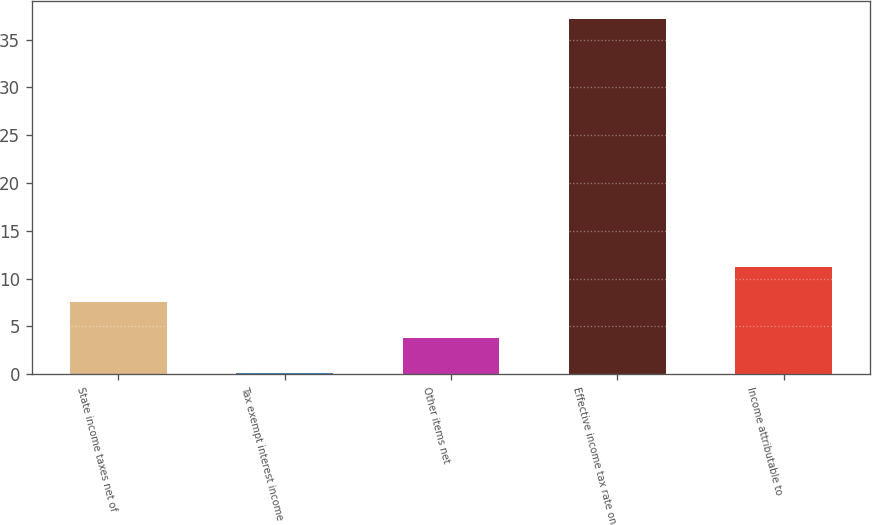<chart> <loc_0><loc_0><loc_500><loc_500><bar_chart><fcel>State income taxes net of<fcel>Tax exempt interest income<fcel>Other items net<fcel>Effective income tax rate on<fcel>Income attributable to<nl><fcel>7.52<fcel>0.1<fcel>3.81<fcel>37.2<fcel>11.23<nl></chart> 